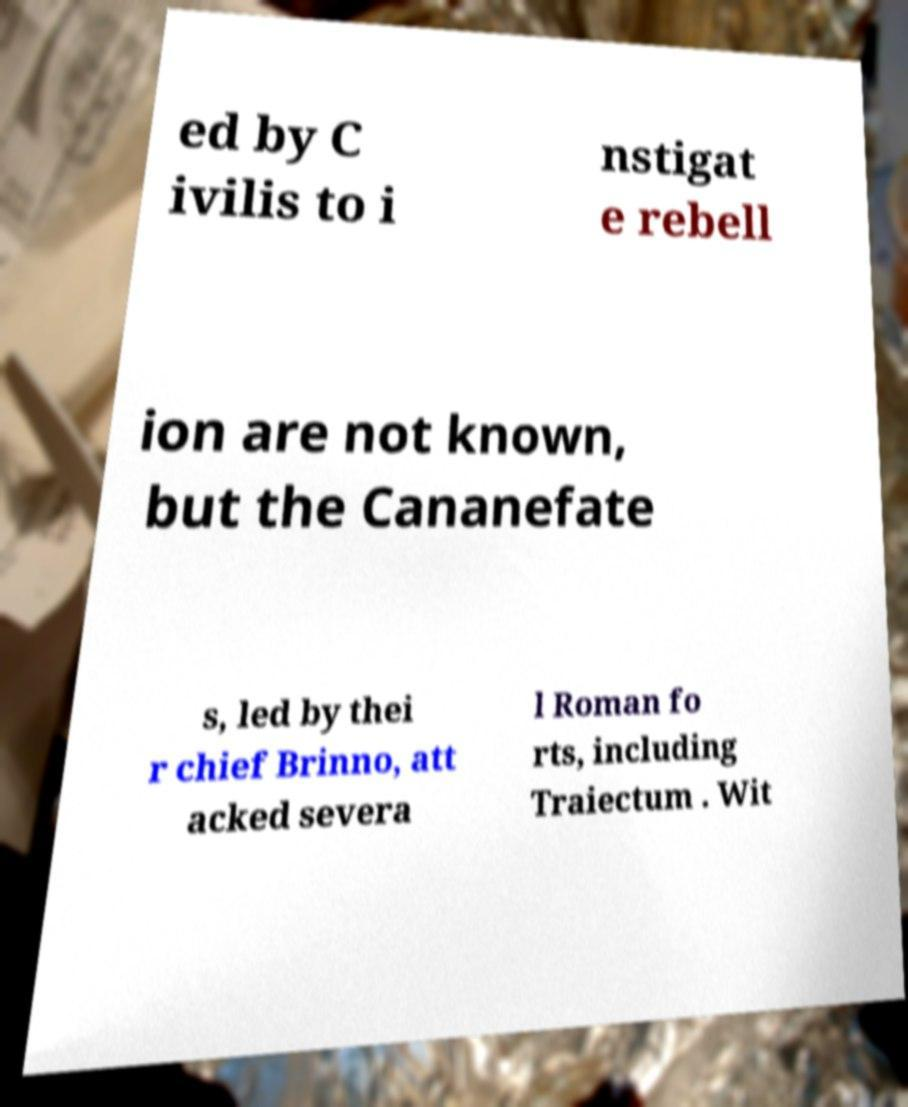There's text embedded in this image that I need extracted. Can you transcribe it verbatim? ed by C ivilis to i nstigat e rebell ion are not known, but the Cananefate s, led by thei r chief Brinno, att acked severa l Roman fo rts, including Traiectum . Wit 